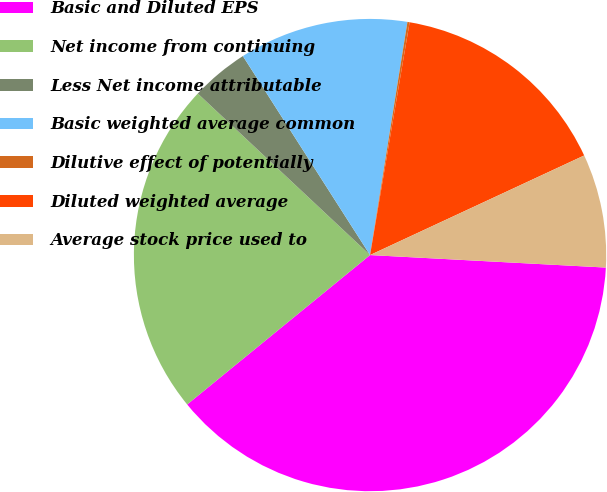Convert chart. <chart><loc_0><loc_0><loc_500><loc_500><pie_chart><fcel>Basic and Diluted EPS<fcel>Net income from continuing<fcel>Less Net income attributable<fcel>Basic weighted average common<fcel>Dilutive effect of potentially<fcel>Diluted weighted average<fcel>Average stock price used to<nl><fcel>38.25%<fcel>22.89%<fcel>3.96%<fcel>11.58%<fcel>0.15%<fcel>15.39%<fcel>7.77%<nl></chart> 